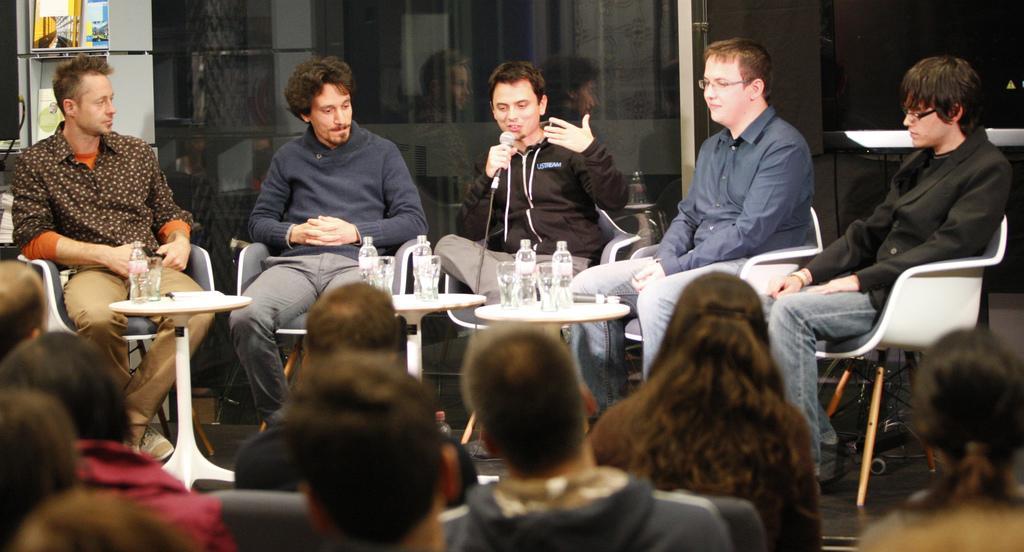Could you give a brief overview of what you see in this image? In this image I can see number of people are sitting on chairs. In the background I can see one of them is holding a mic and in the front of him I can see three tables and on it I can see number of bottles and glasses. On the top left side of this image I can see few stuffs. 